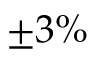Convert formula to latex. <formula><loc_0><loc_0><loc_500><loc_500>\pm 3 \%</formula> 